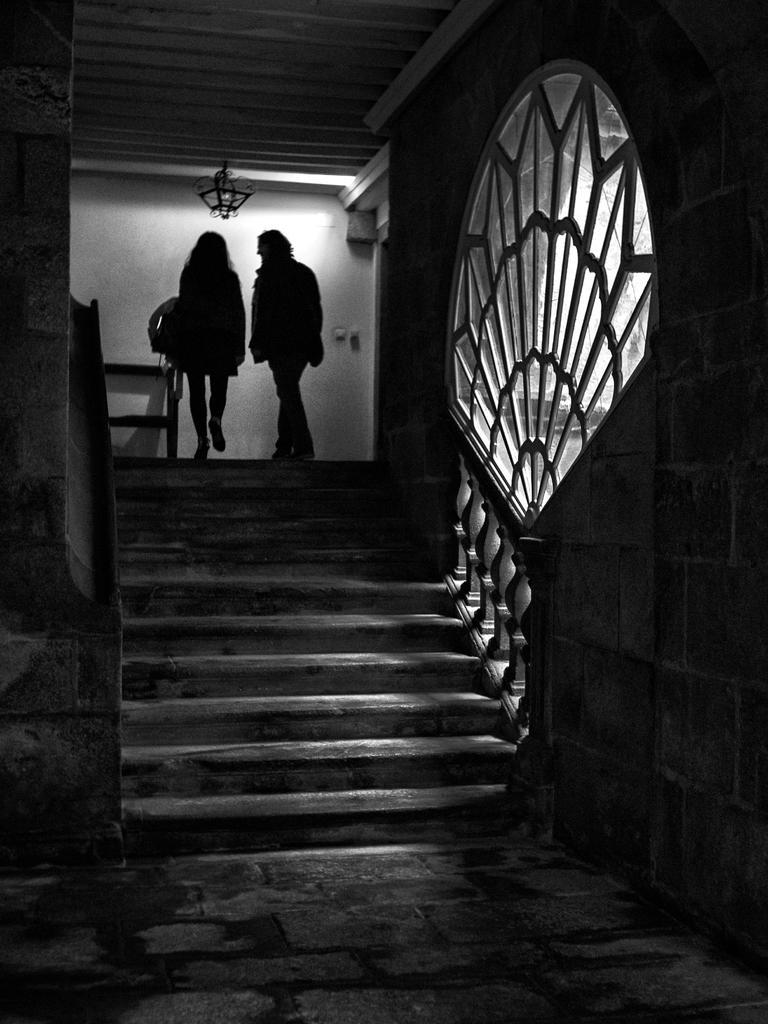Could you give a brief overview of what you see in this image? In this picture I can see there are two people walking at the stairs and there is a glass window on to the left side. 